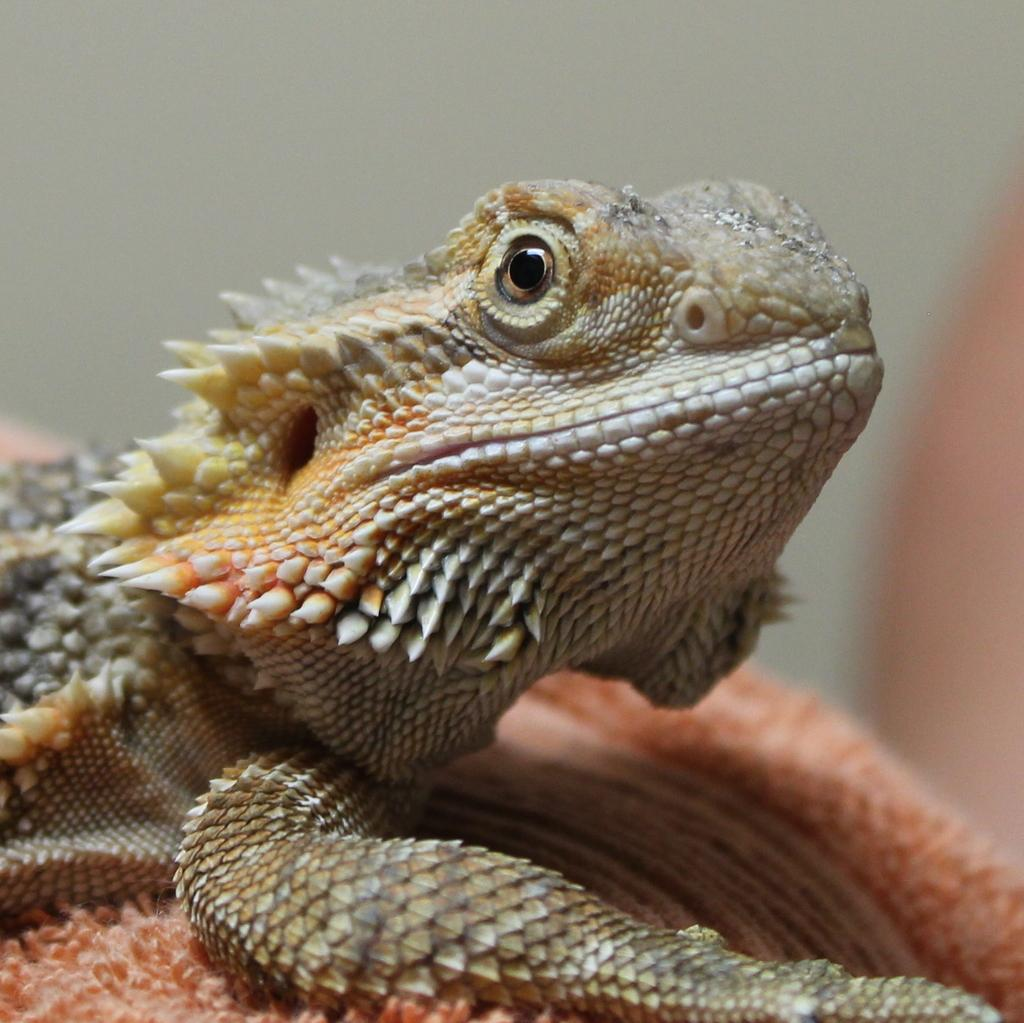What type of animal is in the image? There is a reptile in the image. What is the reptile resting on? The reptile is on a pink-colored object. Can you describe the background of the image? The background of the image is blurred. Are there any fairies visible in the image? No, there are no fairies present in the image. What type of jar is the reptile stored in? There is no jar in the image; the reptile is resting on a pink-colored object. 